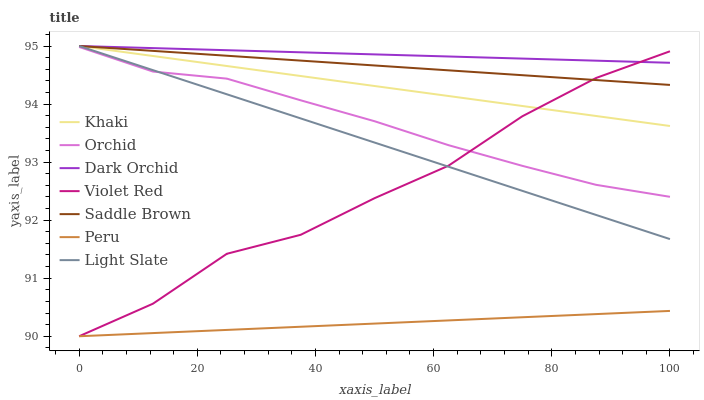Does Peru have the minimum area under the curve?
Answer yes or no. Yes. Does Dark Orchid have the maximum area under the curve?
Answer yes or no. Yes. Does Khaki have the minimum area under the curve?
Answer yes or no. No. Does Khaki have the maximum area under the curve?
Answer yes or no. No. Is Peru the smoothest?
Answer yes or no. Yes. Is Violet Red the roughest?
Answer yes or no. Yes. Is Khaki the smoothest?
Answer yes or no. No. Is Khaki the roughest?
Answer yes or no. No. Does Violet Red have the lowest value?
Answer yes or no. Yes. Does Khaki have the lowest value?
Answer yes or no. No. Does Saddle Brown have the highest value?
Answer yes or no. Yes. Does Peru have the highest value?
Answer yes or no. No. Is Orchid less than Khaki?
Answer yes or no. Yes. Is Khaki greater than Orchid?
Answer yes or no. Yes. Does Khaki intersect Saddle Brown?
Answer yes or no. Yes. Is Khaki less than Saddle Brown?
Answer yes or no. No. Is Khaki greater than Saddle Brown?
Answer yes or no. No. Does Orchid intersect Khaki?
Answer yes or no. No. 